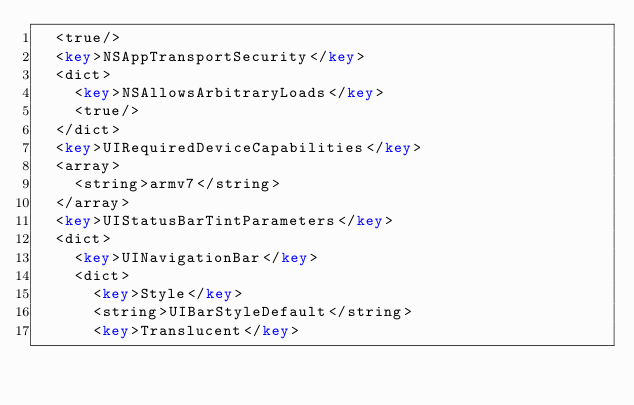Convert code to text. <code><loc_0><loc_0><loc_500><loc_500><_XML_>	<true/>
	<key>NSAppTransportSecurity</key>
	<dict>
		<key>NSAllowsArbitraryLoads</key>
		<true/>
	</dict>
	<key>UIRequiredDeviceCapabilities</key>
	<array>
		<string>armv7</string>
	</array>
	<key>UIStatusBarTintParameters</key>
	<dict>
		<key>UINavigationBar</key>
		<dict>
			<key>Style</key>
			<string>UIBarStyleDefault</string>
			<key>Translucent</key></code> 